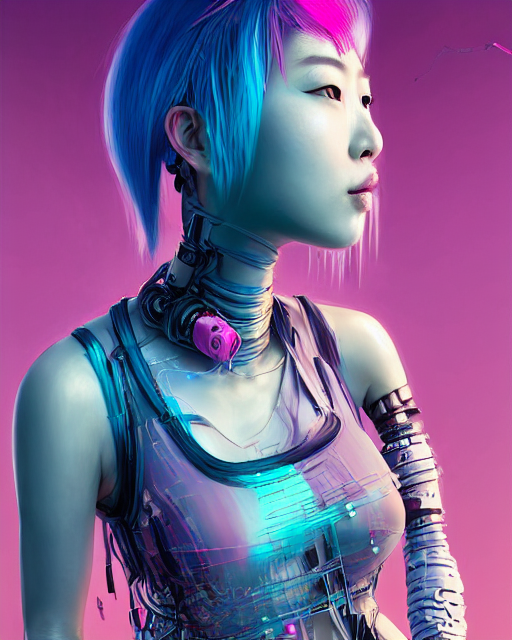Could the design of the clothing be functional for a robot, or is it purely aesthetic? The design of the clothing appears to be a blend of functionality and aesthetics. The transparent sections may allow for venting or showcasing the robot's internal mechanisms, while the overall style contributes to a humanized appearance, potentially to make interactions with humans more relatable. 